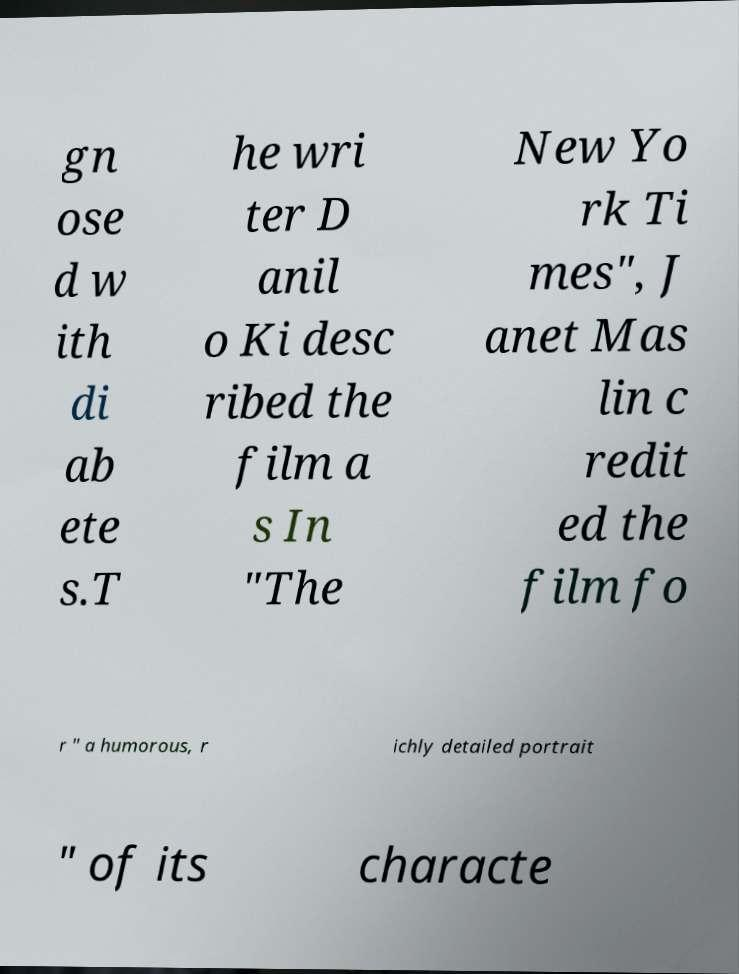Can you read and provide the text displayed in the image?This photo seems to have some interesting text. Can you extract and type it out for me? gn ose d w ith di ab ete s.T he wri ter D anil o Ki desc ribed the film a s In "The New Yo rk Ti mes", J anet Mas lin c redit ed the film fo r " a humorous, r ichly detailed portrait " of its characte 